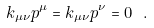Convert formula to latex. <formula><loc_0><loc_0><loc_500><loc_500>k _ { \mu \nu } p ^ { \mu } = k _ { \mu \nu } p ^ { \nu } = 0 \ .</formula> 